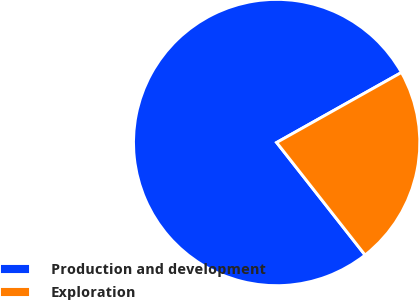Convert chart. <chart><loc_0><loc_0><loc_500><loc_500><pie_chart><fcel>Production and development<fcel>Exploration<nl><fcel>77.46%<fcel>22.54%<nl></chart> 